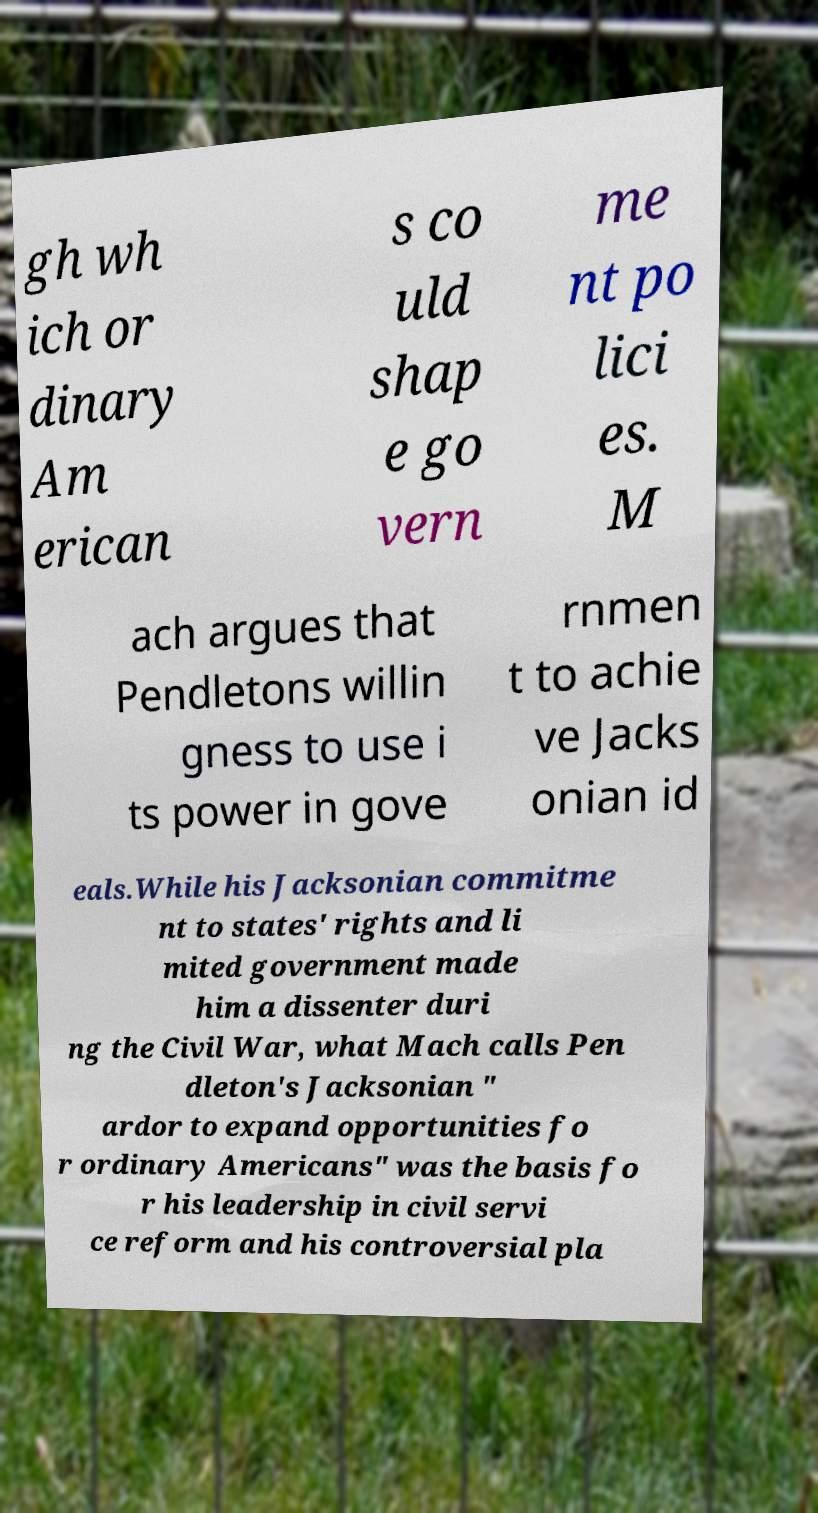Please identify and transcribe the text found in this image. gh wh ich or dinary Am erican s co uld shap e go vern me nt po lici es. M ach argues that Pendletons willin gness to use i ts power in gove rnmen t to achie ve Jacks onian id eals.While his Jacksonian commitme nt to states' rights and li mited government made him a dissenter duri ng the Civil War, what Mach calls Pen dleton's Jacksonian " ardor to expand opportunities fo r ordinary Americans" was the basis fo r his leadership in civil servi ce reform and his controversial pla 